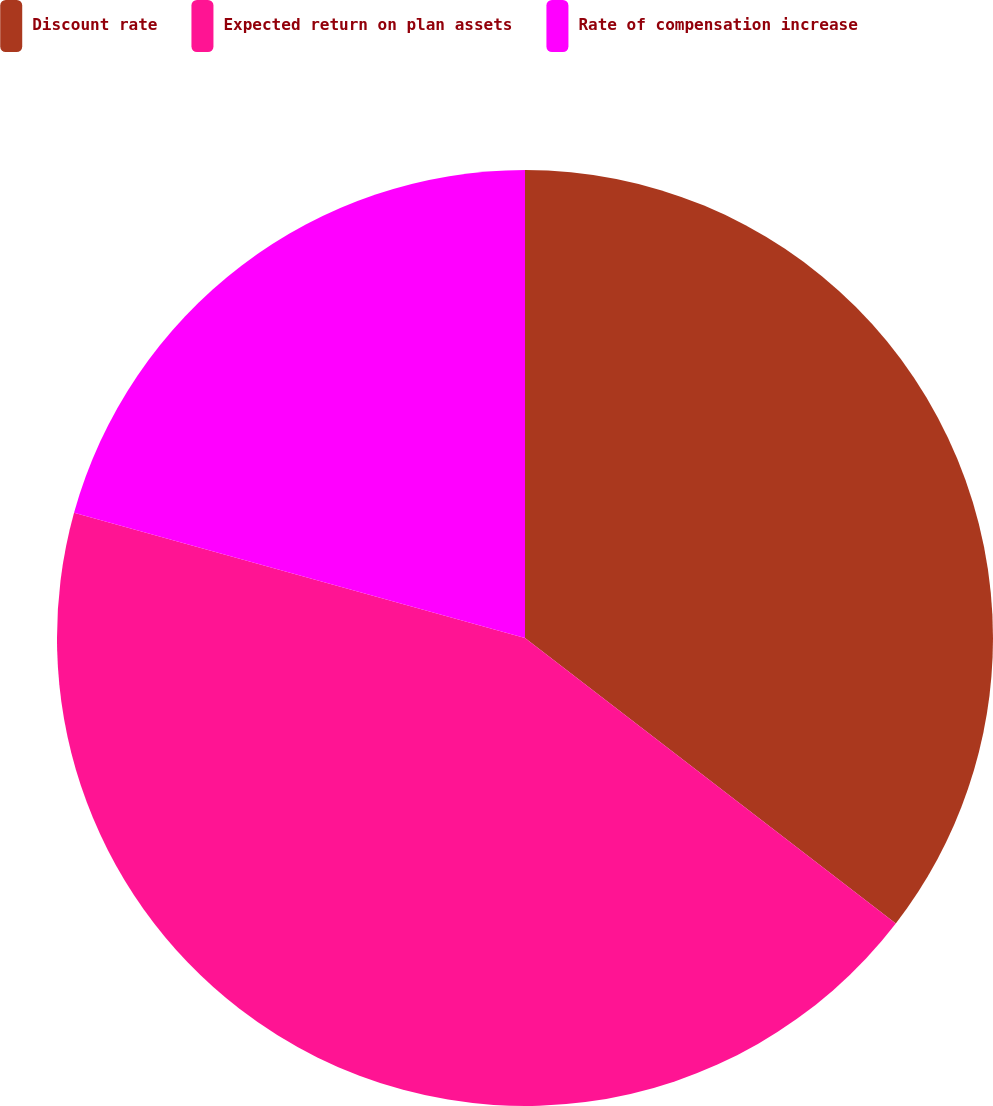Convert chart. <chart><loc_0><loc_0><loc_500><loc_500><pie_chart><fcel>Discount rate<fcel>Expected return on plan assets<fcel>Rate of compensation increase<nl><fcel>35.44%<fcel>43.86%<fcel>20.69%<nl></chart> 